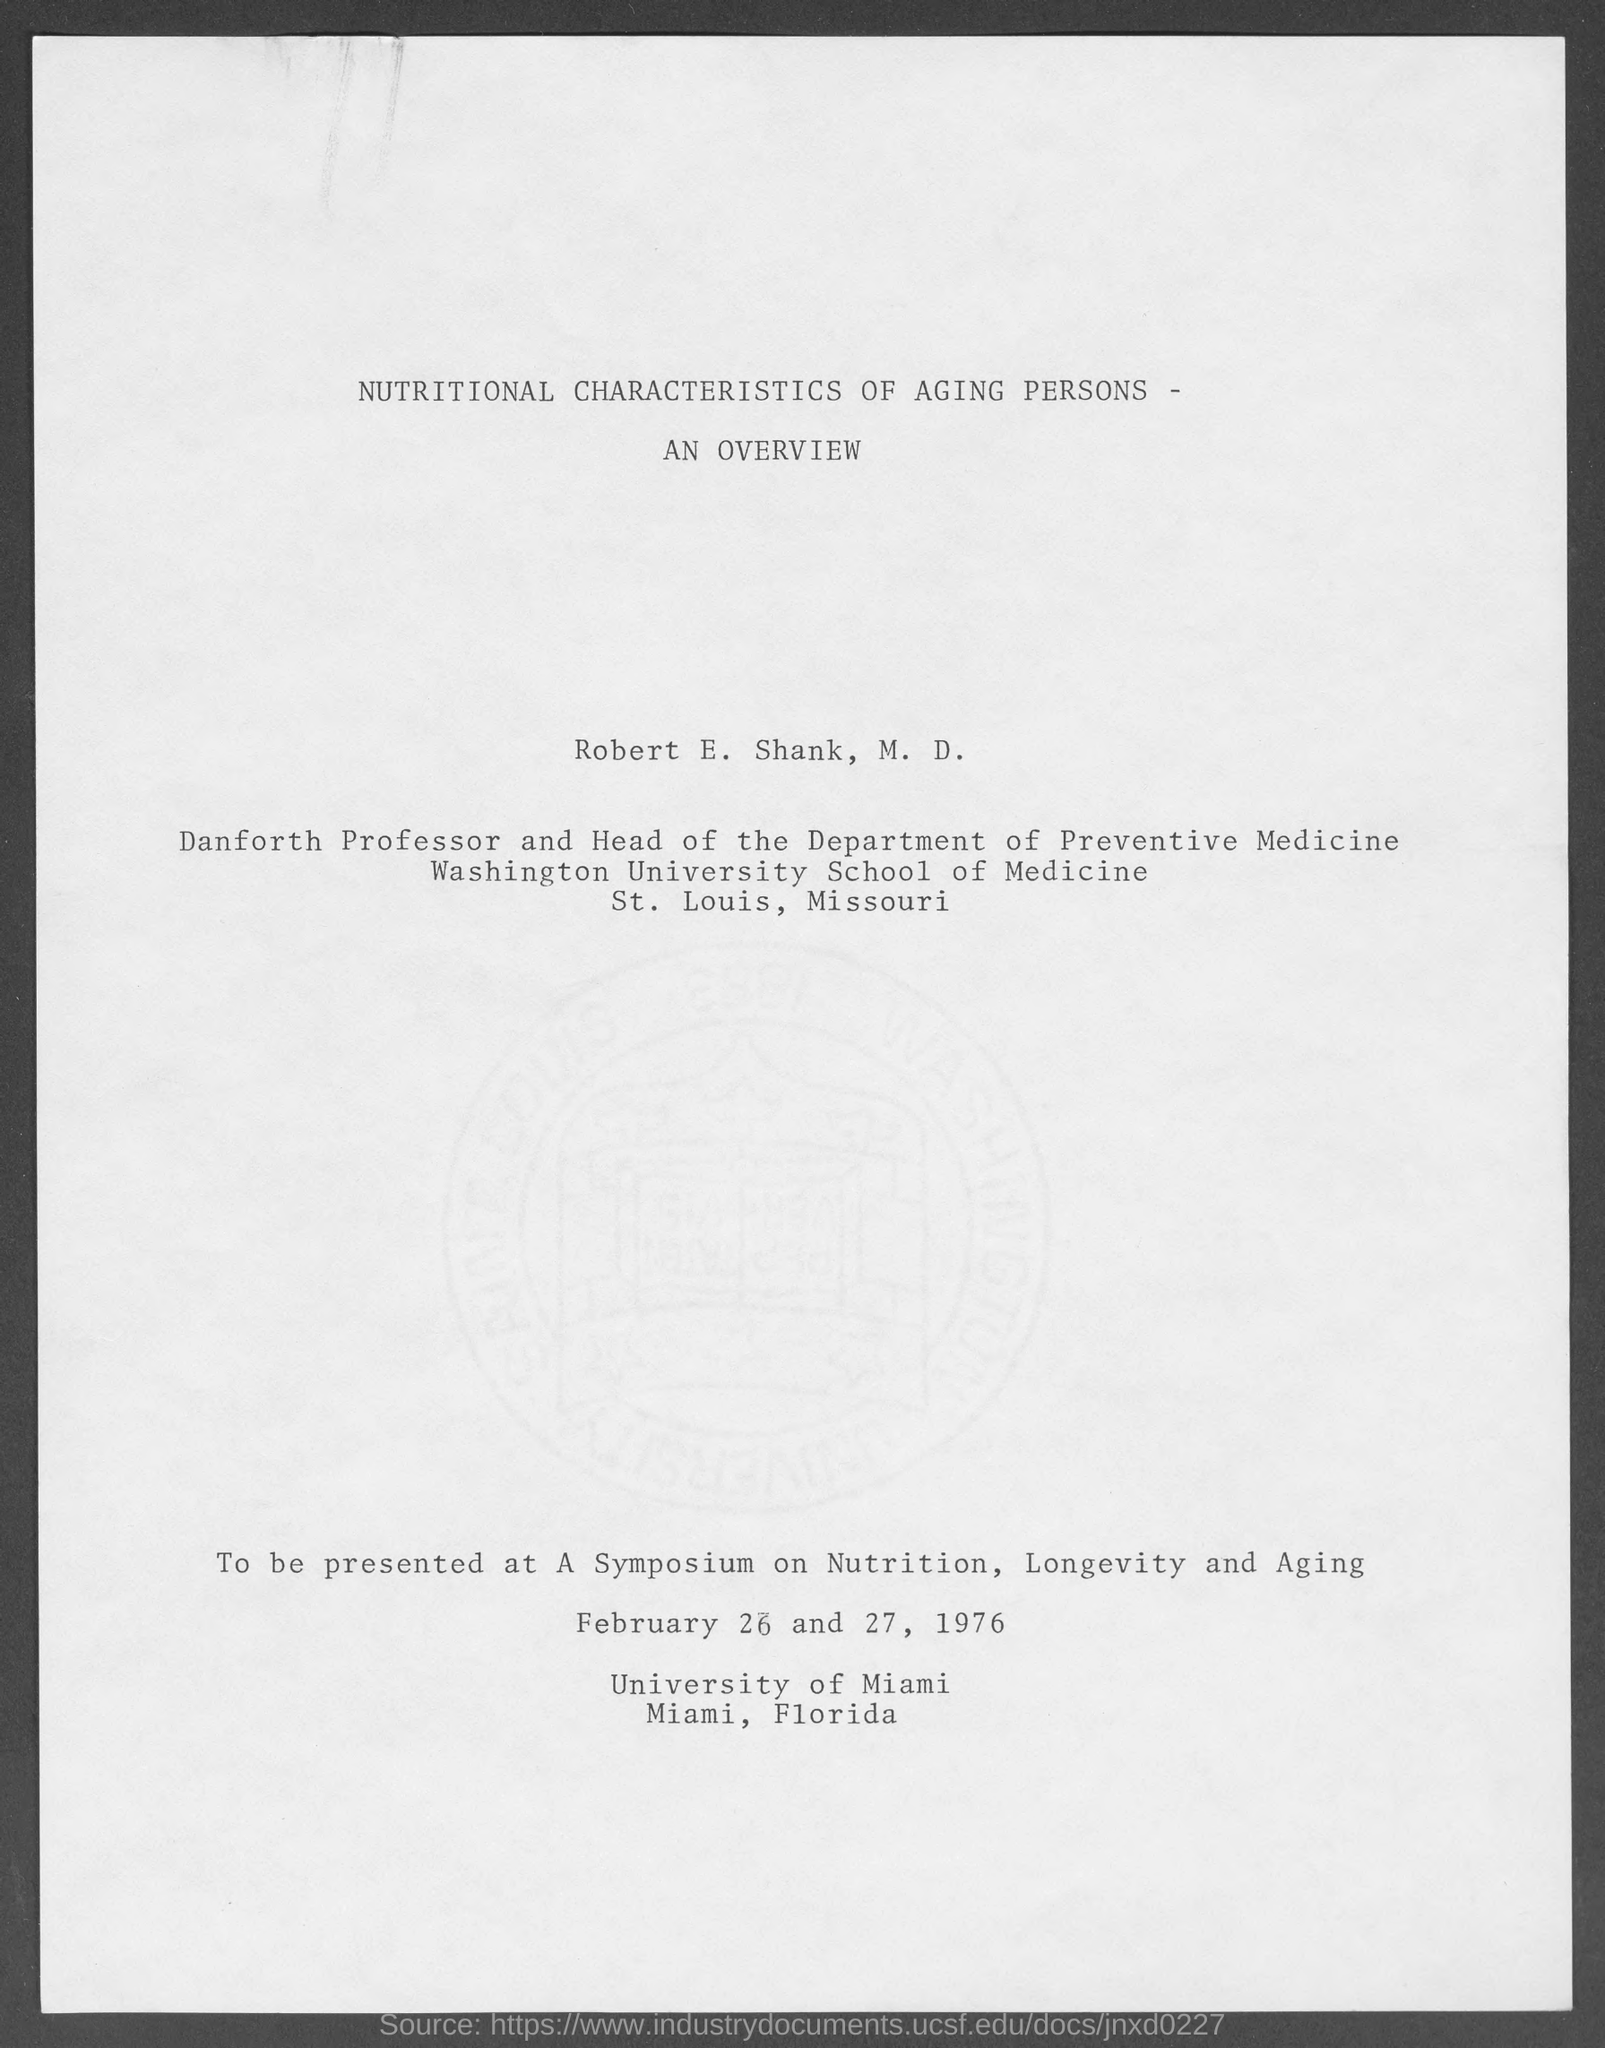What is the title of the document?
Provide a succinct answer. Nutritional characteristics of aging persons - an overview. Who is the head of the Department of Preventive Medicine?
Keep it short and to the point. Robert E. Shank. 